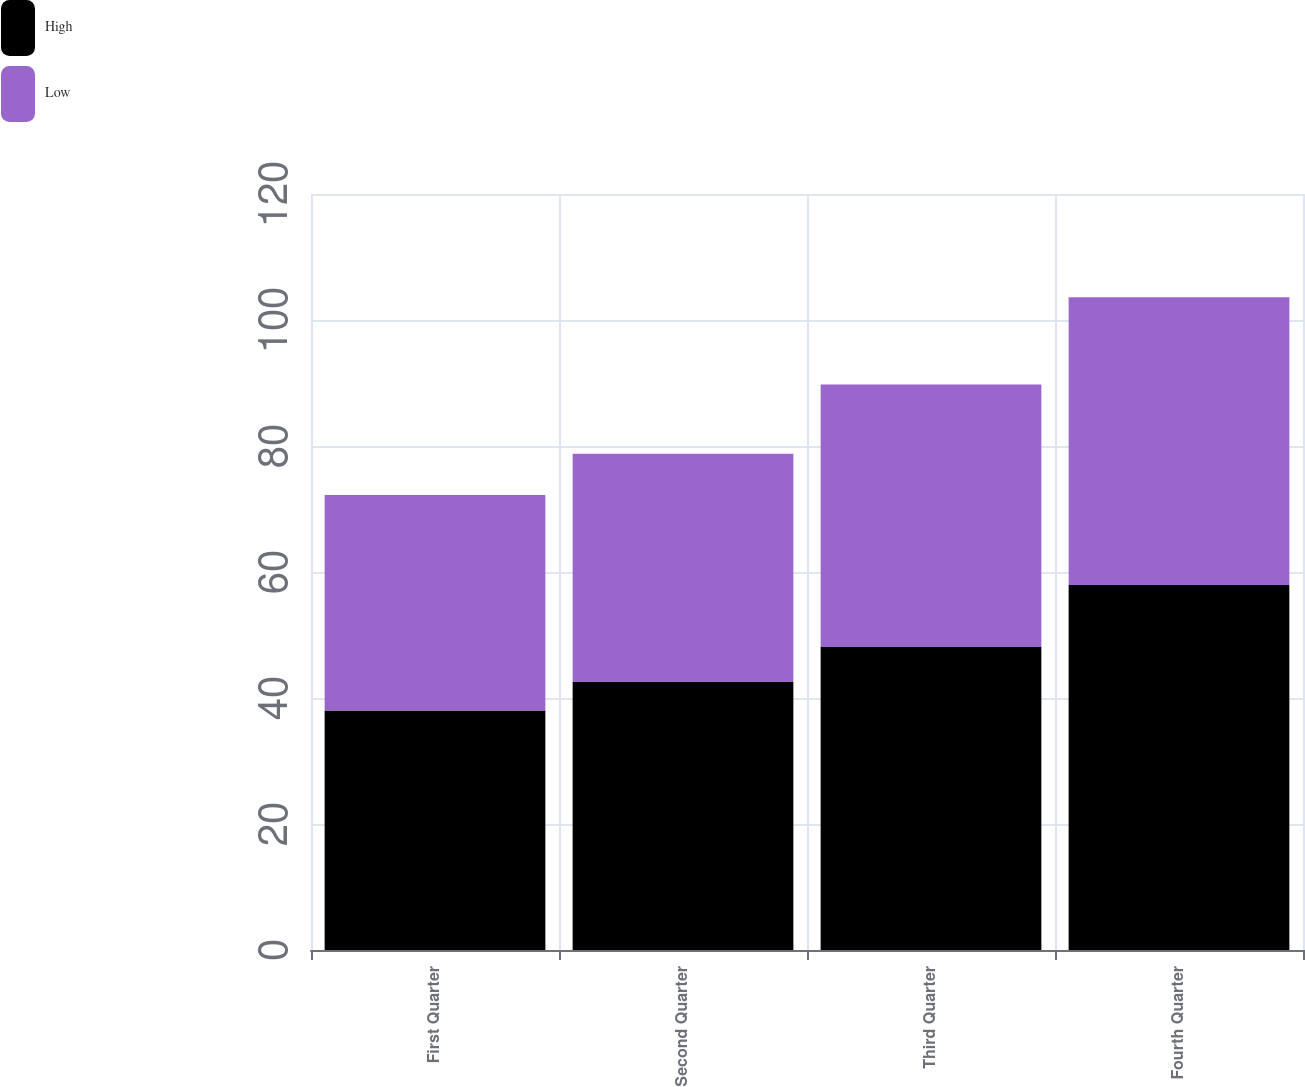<chart> <loc_0><loc_0><loc_500><loc_500><stacked_bar_chart><ecel><fcel>First Quarter<fcel>Second Quarter<fcel>Third Quarter<fcel>Fourth Quarter<nl><fcel>High<fcel>38.02<fcel>42.52<fcel>48.09<fcel>57.92<nl><fcel>Low<fcel>34.19<fcel>36.24<fcel>41.66<fcel>45.68<nl></chart> 